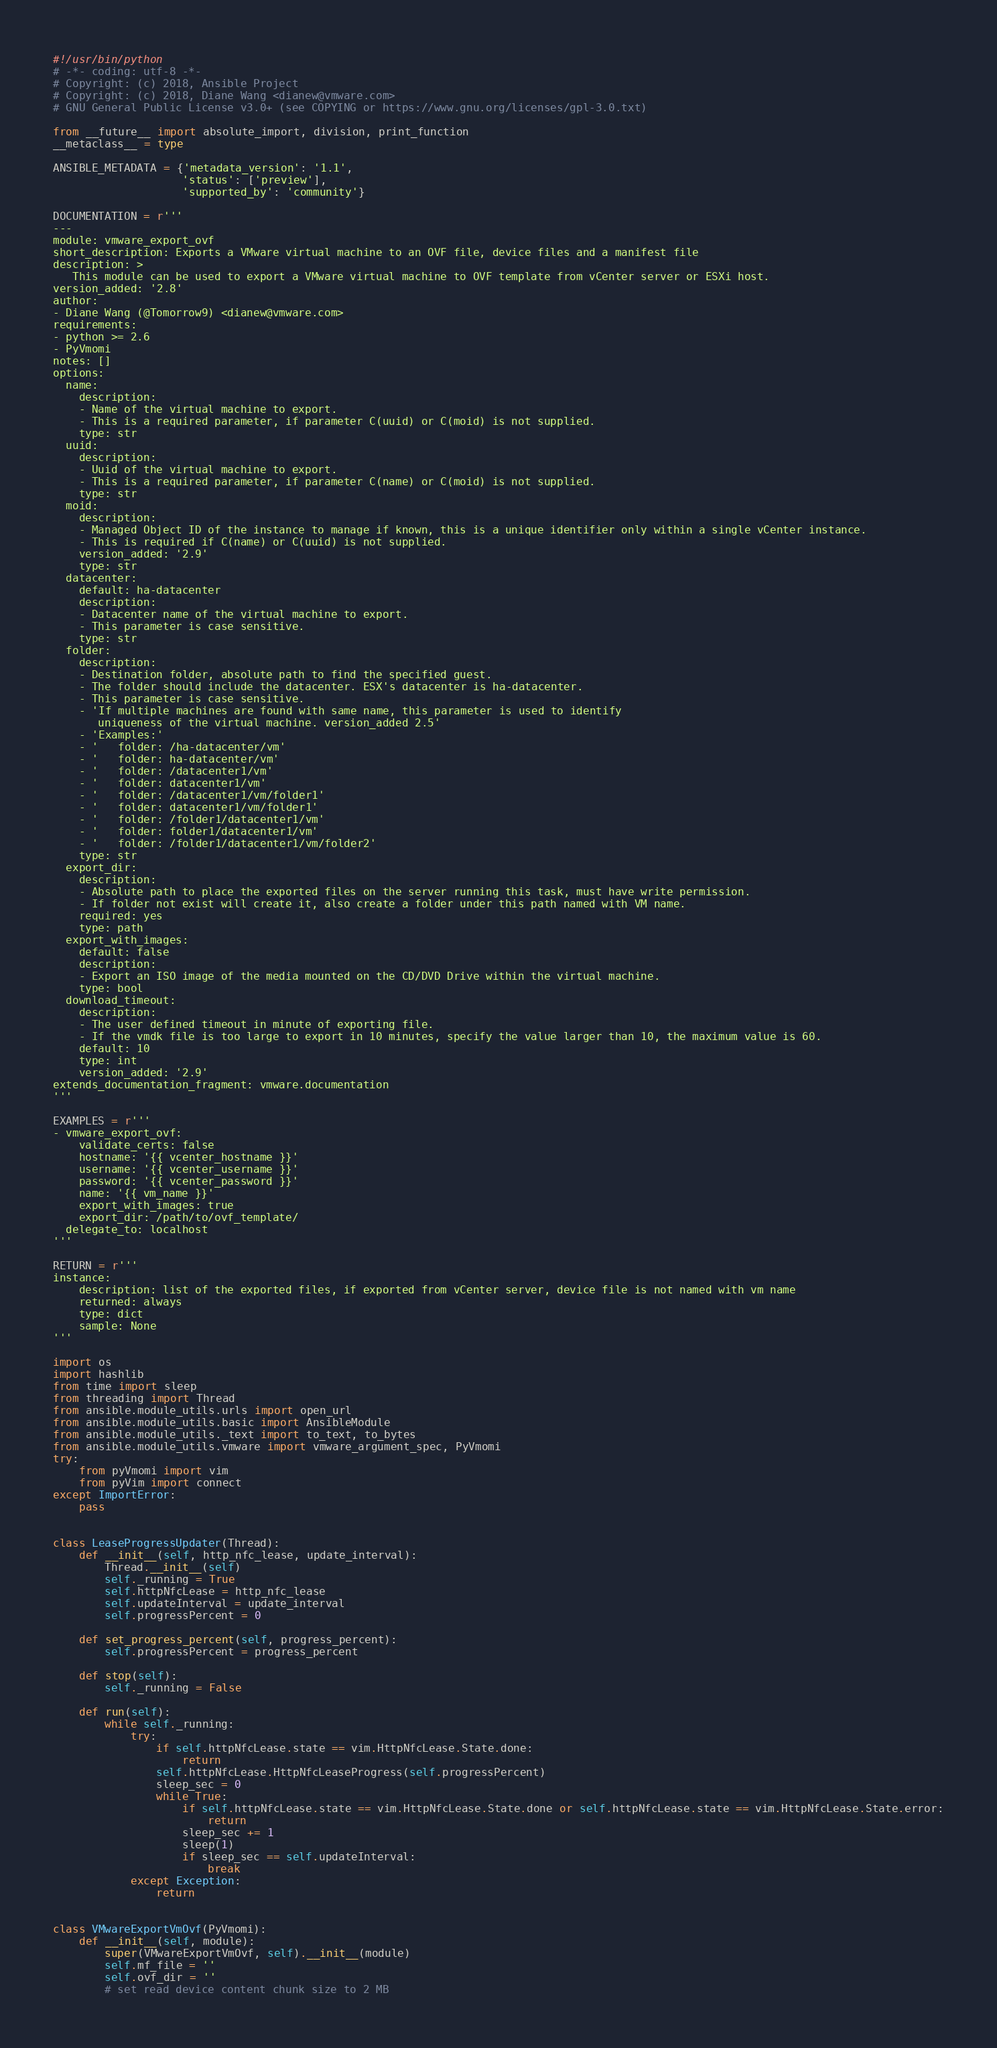<code> <loc_0><loc_0><loc_500><loc_500><_Python_>#!/usr/bin/python
# -*- coding: utf-8 -*-
# Copyright: (c) 2018, Ansible Project
# Copyright: (c) 2018, Diane Wang <dianew@vmware.com>
# GNU General Public License v3.0+ (see COPYING or https://www.gnu.org/licenses/gpl-3.0.txt)

from __future__ import absolute_import, division, print_function
__metaclass__ = type

ANSIBLE_METADATA = {'metadata_version': '1.1',
                    'status': ['preview'],
                    'supported_by': 'community'}

DOCUMENTATION = r'''
---
module: vmware_export_ovf
short_description: Exports a VMware virtual machine to an OVF file, device files and a manifest file
description: >
   This module can be used to export a VMware virtual machine to OVF template from vCenter server or ESXi host.
version_added: '2.8'
author:
- Diane Wang (@Tomorrow9) <dianew@vmware.com>
requirements:
- python >= 2.6
- PyVmomi
notes: []
options:
  name:
    description:
    - Name of the virtual machine to export.
    - This is a required parameter, if parameter C(uuid) or C(moid) is not supplied.
    type: str
  uuid:
    description:
    - Uuid of the virtual machine to export.
    - This is a required parameter, if parameter C(name) or C(moid) is not supplied.
    type: str
  moid:
    description:
    - Managed Object ID of the instance to manage if known, this is a unique identifier only within a single vCenter instance.
    - This is required if C(name) or C(uuid) is not supplied.
    version_added: '2.9'
    type: str
  datacenter:
    default: ha-datacenter
    description:
    - Datacenter name of the virtual machine to export.
    - This parameter is case sensitive.
    type: str
  folder:
    description:
    - Destination folder, absolute path to find the specified guest.
    - The folder should include the datacenter. ESX's datacenter is ha-datacenter.
    - This parameter is case sensitive.
    - 'If multiple machines are found with same name, this parameter is used to identify
       uniqueness of the virtual machine. version_added 2.5'
    - 'Examples:'
    - '   folder: /ha-datacenter/vm'
    - '   folder: ha-datacenter/vm'
    - '   folder: /datacenter1/vm'
    - '   folder: datacenter1/vm'
    - '   folder: /datacenter1/vm/folder1'
    - '   folder: datacenter1/vm/folder1'
    - '   folder: /folder1/datacenter1/vm'
    - '   folder: folder1/datacenter1/vm'
    - '   folder: /folder1/datacenter1/vm/folder2'
    type: str
  export_dir:
    description:
    - Absolute path to place the exported files on the server running this task, must have write permission.
    - If folder not exist will create it, also create a folder under this path named with VM name.
    required: yes
    type: path
  export_with_images:
    default: false
    description:
    - Export an ISO image of the media mounted on the CD/DVD Drive within the virtual machine.
    type: bool
  download_timeout:
    description:
    - The user defined timeout in minute of exporting file.
    - If the vmdk file is too large to export in 10 minutes, specify the value larger than 10, the maximum value is 60.
    default: 10
    type: int
    version_added: '2.9'
extends_documentation_fragment: vmware.documentation
'''

EXAMPLES = r'''
- vmware_export_ovf:
    validate_certs: false
    hostname: '{{ vcenter_hostname }}'
    username: '{{ vcenter_username }}'
    password: '{{ vcenter_password }}'
    name: '{{ vm_name }}'
    export_with_images: true
    export_dir: /path/to/ovf_template/
  delegate_to: localhost
'''

RETURN = r'''
instance:
    description: list of the exported files, if exported from vCenter server, device file is not named with vm name
    returned: always
    type: dict
    sample: None
'''

import os
import hashlib
from time import sleep
from threading import Thread
from ansible.module_utils.urls import open_url
from ansible.module_utils.basic import AnsibleModule
from ansible.module_utils._text import to_text, to_bytes
from ansible.module_utils.vmware import vmware_argument_spec, PyVmomi
try:
    from pyVmomi import vim
    from pyVim import connect
except ImportError:
    pass


class LeaseProgressUpdater(Thread):
    def __init__(self, http_nfc_lease, update_interval):
        Thread.__init__(self)
        self._running = True
        self.httpNfcLease = http_nfc_lease
        self.updateInterval = update_interval
        self.progressPercent = 0

    def set_progress_percent(self, progress_percent):
        self.progressPercent = progress_percent

    def stop(self):
        self._running = False

    def run(self):
        while self._running:
            try:
                if self.httpNfcLease.state == vim.HttpNfcLease.State.done:
                    return
                self.httpNfcLease.HttpNfcLeaseProgress(self.progressPercent)
                sleep_sec = 0
                while True:
                    if self.httpNfcLease.state == vim.HttpNfcLease.State.done or self.httpNfcLease.state == vim.HttpNfcLease.State.error:
                        return
                    sleep_sec += 1
                    sleep(1)
                    if sleep_sec == self.updateInterval:
                        break
            except Exception:
                return


class VMwareExportVmOvf(PyVmomi):
    def __init__(self, module):
        super(VMwareExportVmOvf, self).__init__(module)
        self.mf_file = ''
        self.ovf_dir = ''
        # set read device content chunk size to 2 MB</code> 